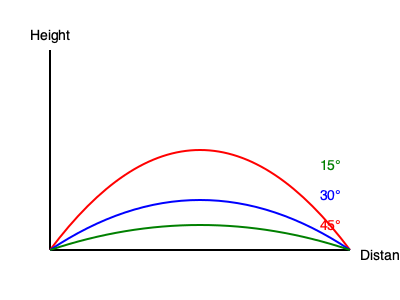In a local football match at Motera Stadium, three players attempt long-distance kicks with the same initial velocity but different angles. Based on the diagram showing the trajectories of these kicks, which angle would result in the maximum distance covered by the football? To determine which angle results in the maximum distance, we need to analyze the trajectories shown in the diagram:

1. The diagram shows three different trajectories: red (45°), blue (30°), and green (15°).

2. In projectile motion, the distance traveled depends on the initial velocity and the angle of projection.

3. The formula for the range (R) of a projectile is:
   $$ R = \frac{v^2 \sin(2\theta)}{g} $$
   Where $v$ is the initial velocity, $\theta$ is the angle of projection, and $g$ is the acceleration due to gravity.

4. The maximum range occurs when $\sin(2\theta)$ is at its maximum value, which happens when $2\theta = 90°$ or $\theta = 45°$.

5. In the diagram, we can see that the red trajectory (45°) reaches the same distance as the other two trajectories but achieves a greater height.

6. This greater height allows the 45° kick to cover more distance if there were no obstacles or if the field were longer.

Therefore, the 45° angle (red trajectory) would result in the maximum distance covered by the football.
Answer: 45° 